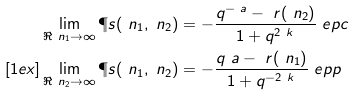<formula> <loc_0><loc_0><loc_500><loc_500>& \lim _ { \Re \ n _ { 1 } \rightarrow \infty } \P s ( \ n _ { 1 } , \ n _ { 2 } ) = - \frac { q ^ { - \ a } - \ r ( \ n _ { 2 } ) } { 1 + q ^ { 2 \ k } } \ e p c \\ [ 1 e x ] & \lim _ { \Re \ n _ { 2 } \rightarrow \infty } \P s ( \ n _ { 1 } , \ n _ { 2 } ) = - \frac { q ^ { \ } a - \ r ( \ n _ { 1 } ) } { 1 + q ^ { - 2 \ k } } \ e p p</formula> 